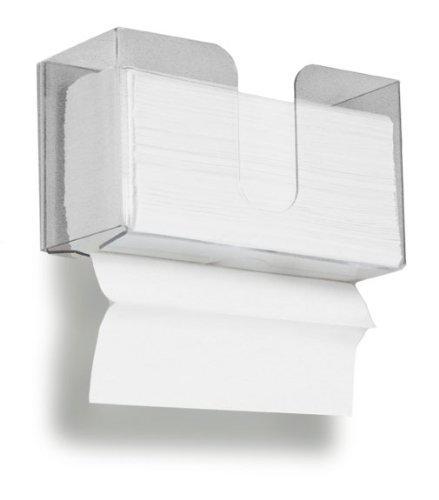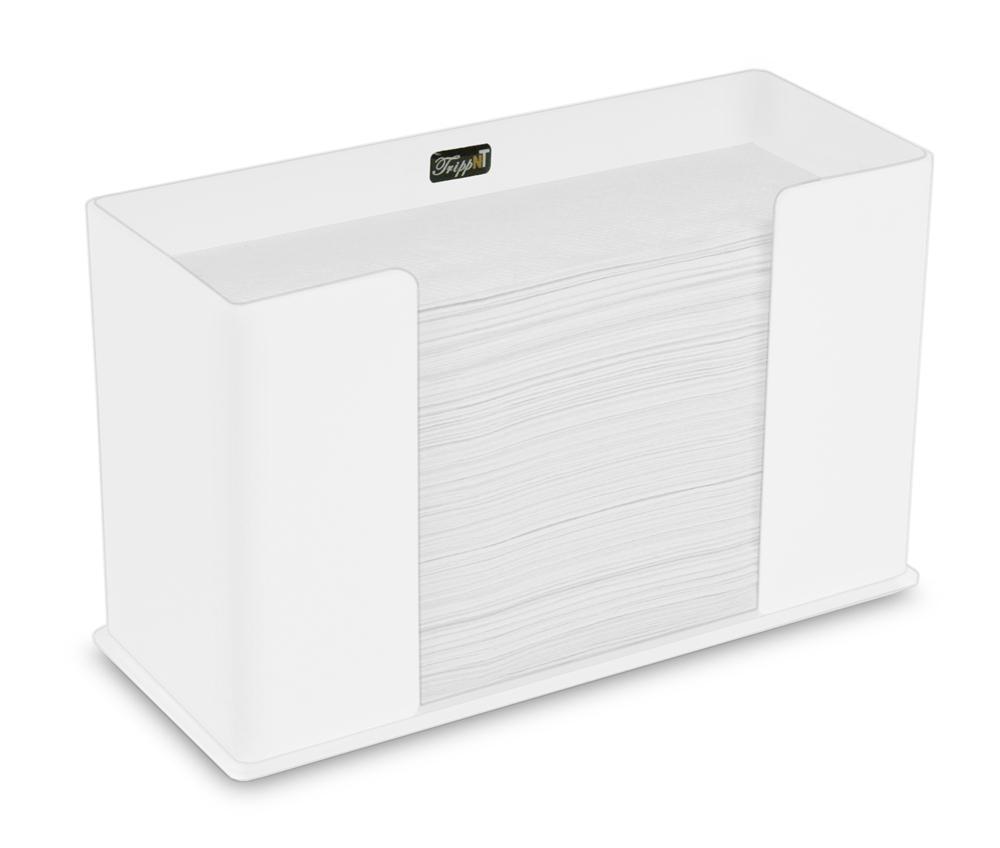The first image is the image on the left, the second image is the image on the right. For the images shown, is this caption "In at least one image there is a clear plastic paper towel holder with the white paper towel coming out the bottom." true? Answer yes or no. Yes. The first image is the image on the left, the second image is the image on the right. Given the left and right images, does the statement "A clear paper towel holder is full and has one towel hanging out the bottom." hold true? Answer yes or no. Yes. 